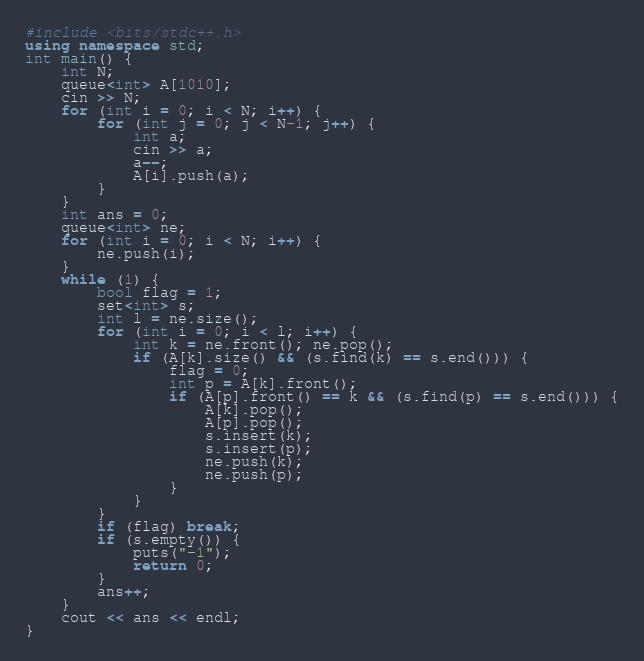Convert code to text. <code><loc_0><loc_0><loc_500><loc_500><_C++_>#include <bits/stdc++.h>
using namespace std;
int main() {
	int N;
	queue<int> A[1010];
	cin >> N;
	for (int i = 0; i < N; i++) {
		for (int j = 0; j < N-1; j++) {
			int a;
			cin >> a;
			a--;
			A[i].push(a);
		}
	}
	int ans = 0;
	queue<int> ne;
	for (int i = 0; i < N; i++) {
		ne.push(i);
	}
	while (1) {
		bool flag = 1;
		set<int> s;
		int l = ne.size();
		for (int i = 0; i < l; i++) {
			int k = ne.front(); ne.pop();
			if (A[k].size() && (s.find(k) == s.end())) {
				flag = 0;
				int p = A[k].front();
				if (A[p].front() == k && (s.find(p) == s.end())) {
					A[k].pop();
					A[p].pop();
					s.insert(k);
					s.insert(p);
					ne.push(k);
					ne.push(p);
				}
			}
		}
		if (flag) break;
		if (s.empty()) {
			puts("-1");
			return 0;
		}
		ans++;
	}
	cout << ans << endl;
}</code> 